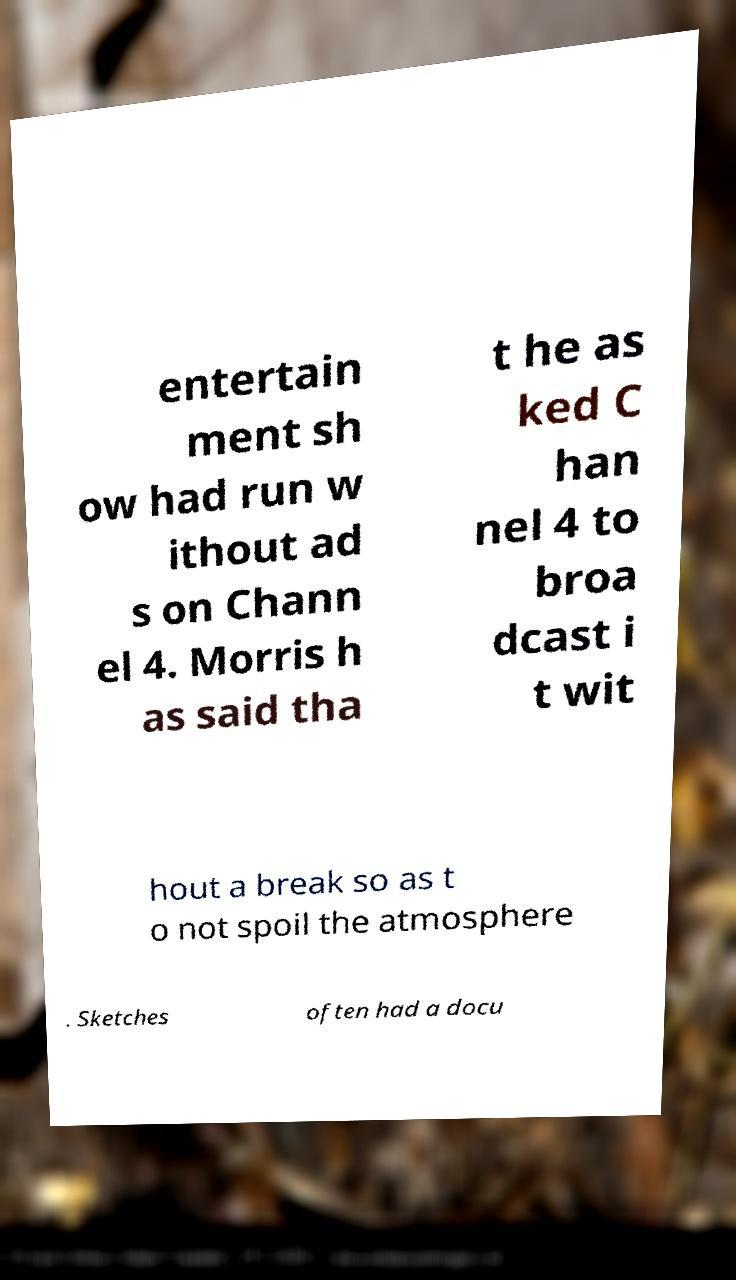Could you extract and type out the text from this image? entertain ment sh ow had run w ithout ad s on Chann el 4. Morris h as said tha t he as ked C han nel 4 to broa dcast i t wit hout a break so as t o not spoil the atmosphere . Sketches often had a docu 